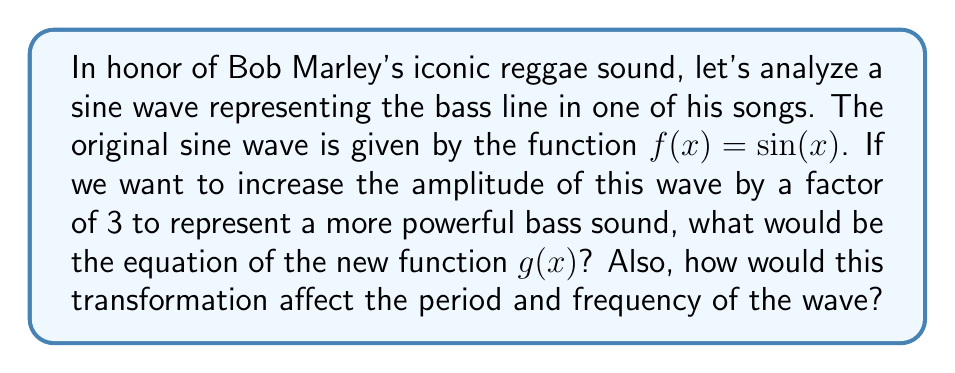Solve this math problem. To solve this problem, let's break it down step by step:

1) The original function is $f(x) = \sin(x)$. This represents a standard sine wave with an amplitude of 1.

2) To increase the amplitude by a factor of 3, we need to multiply the entire function by 3. This is called a vertical stretch.

3) The new function $g(x)$ can be written as:

   $g(x) = 3\sin(x)$

4) This transformation affects the amplitude of the wave, but it does not change the period or frequency of the wave. Here's why:

   - Amplitude: The amplitude is the distance from the midline to the peak (or trough) of the wave. In the original function, this was 1. In the new function, it's 3.
   
   - Period: The period of a sine function is determined by what's inside the parentheses. Since we didn't change anything inside the parentheses, the period remains $2\pi$.
   
   - Frequency: The frequency is the reciprocal of the period. Since the period didn't change, the frequency also remains the same.

5) To visualize this, we can imagine the wave becoming taller (higher peaks and lower troughs), but the distance between peaks (period) stays the same.

[asy]
import graph;
size(200,150);
real f(real x) {return sin(x);}
real g(real x) {return 3*sin(x);}
draw(graph(f,-pi,pi),blue);
draw(graph(g,-pi,pi),red);
xaxis("x");
yaxis("y");
label("$f(x)=\sin(x)$",(pi,1),NE,blue);
label("$g(x)=3\sin(x)$",(pi/2,3),N,red);
[/asy]

In the context of reggae music, this transformation could represent increasing the volume or intensity of the bass line while maintaining its rhythm (frequency).
Answer: The new function is $g(x) = 3\sin(x)$. This vertical stretch increases the amplitude by a factor of 3 but does not affect the period or frequency of the wave. 